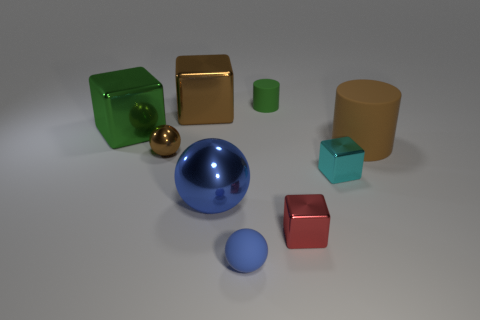Subtract all brown cubes. How many cubes are left? 3 Add 1 small green objects. How many objects exist? 10 Subtract all red cubes. How many cubes are left? 3 Subtract all cylinders. How many objects are left? 7 Subtract 2 cylinders. How many cylinders are left? 0 Subtract all yellow cubes. How many brown balls are left? 1 Subtract all green blocks. Subtract all cyan spheres. How many blocks are left? 3 Subtract all large blue objects. Subtract all large brown metal objects. How many objects are left? 7 Add 3 big blue metallic spheres. How many big blue metallic spheres are left? 4 Add 6 big brown shiny objects. How many big brown shiny objects exist? 7 